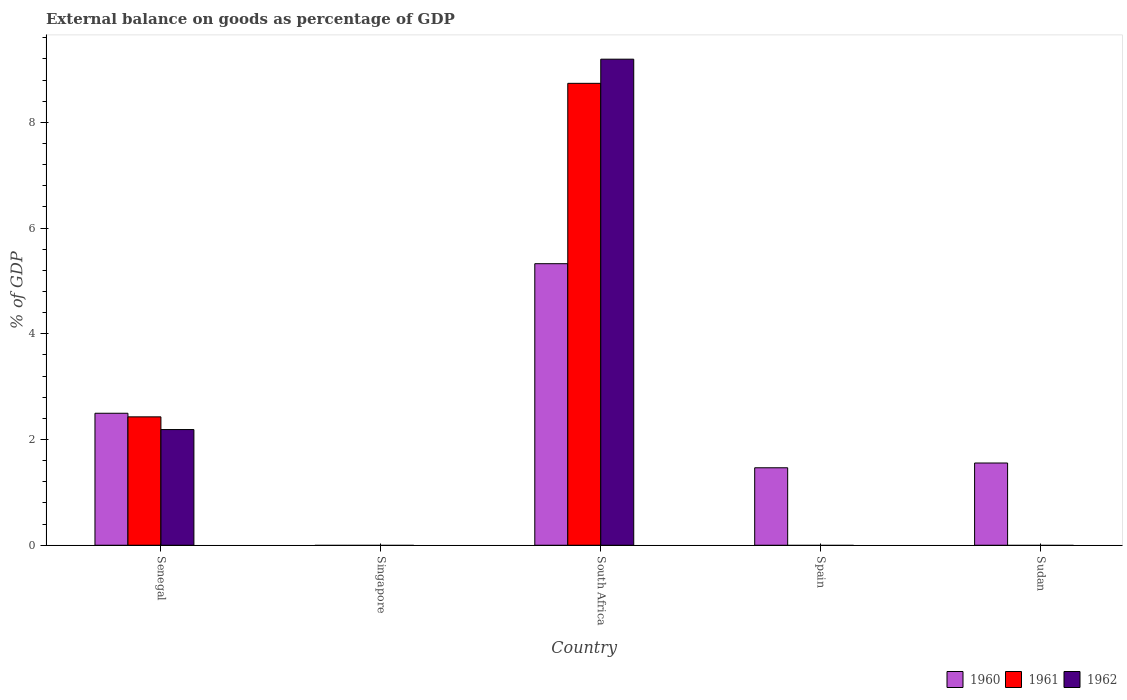Are the number of bars per tick equal to the number of legend labels?
Give a very brief answer. No. Are the number of bars on each tick of the X-axis equal?
Offer a terse response. No. How many bars are there on the 4th tick from the left?
Your response must be concise. 1. How many bars are there on the 5th tick from the right?
Make the answer very short. 3. What is the label of the 1st group of bars from the left?
Your response must be concise. Senegal. What is the external balance on goods as percentage of GDP in 1961 in Sudan?
Provide a short and direct response. 0. Across all countries, what is the maximum external balance on goods as percentage of GDP in 1962?
Give a very brief answer. 9.19. In which country was the external balance on goods as percentage of GDP in 1962 maximum?
Make the answer very short. South Africa. What is the total external balance on goods as percentage of GDP in 1962 in the graph?
Give a very brief answer. 11.38. What is the difference between the external balance on goods as percentage of GDP in 1960 in Spain and that in Sudan?
Ensure brevity in your answer.  -0.09. What is the average external balance on goods as percentage of GDP in 1961 per country?
Offer a terse response. 2.23. What is the difference between the external balance on goods as percentage of GDP of/in 1962 and external balance on goods as percentage of GDP of/in 1960 in South Africa?
Give a very brief answer. 3.87. What is the ratio of the external balance on goods as percentage of GDP in 1960 in Senegal to that in Spain?
Provide a succinct answer. 1.7. What is the difference between the highest and the second highest external balance on goods as percentage of GDP in 1960?
Provide a succinct answer. -0.94. What is the difference between the highest and the lowest external balance on goods as percentage of GDP in 1962?
Ensure brevity in your answer.  9.19. In how many countries, is the external balance on goods as percentage of GDP in 1960 greater than the average external balance on goods as percentage of GDP in 1960 taken over all countries?
Make the answer very short. 2. Is the sum of the external balance on goods as percentage of GDP in 1960 in Senegal and Sudan greater than the maximum external balance on goods as percentage of GDP in 1961 across all countries?
Provide a short and direct response. No. Are all the bars in the graph horizontal?
Offer a terse response. No. How many countries are there in the graph?
Make the answer very short. 5. How many legend labels are there?
Offer a very short reply. 3. What is the title of the graph?
Ensure brevity in your answer.  External balance on goods as percentage of GDP. Does "1978" appear as one of the legend labels in the graph?
Keep it short and to the point. No. What is the label or title of the X-axis?
Make the answer very short. Country. What is the label or title of the Y-axis?
Your answer should be compact. % of GDP. What is the % of GDP of 1960 in Senegal?
Keep it short and to the point. 2.5. What is the % of GDP of 1961 in Senegal?
Keep it short and to the point. 2.43. What is the % of GDP of 1962 in Senegal?
Keep it short and to the point. 2.19. What is the % of GDP in 1960 in Singapore?
Your answer should be very brief. 0. What is the % of GDP of 1961 in Singapore?
Provide a short and direct response. 0. What is the % of GDP of 1962 in Singapore?
Ensure brevity in your answer.  0. What is the % of GDP of 1960 in South Africa?
Offer a terse response. 5.33. What is the % of GDP of 1961 in South Africa?
Keep it short and to the point. 8.74. What is the % of GDP in 1962 in South Africa?
Your response must be concise. 9.19. What is the % of GDP in 1960 in Spain?
Ensure brevity in your answer.  1.47. What is the % of GDP in 1962 in Spain?
Your answer should be compact. 0. What is the % of GDP in 1960 in Sudan?
Keep it short and to the point. 1.56. Across all countries, what is the maximum % of GDP of 1960?
Offer a terse response. 5.33. Across all countries, what is the maximum % of GDP in 1961?
Your answer should be compact. 8.74. Across all countries, what is the maximum % of GDP of 1962?
Provide a short and direct response. 9.19. Across all countries, what is the minimum % of GDP in 1961?
Your response must be concise. 0. Across all countries, what is the minimum % of GDP of 1962?
Keep it short and to the point. 0. What is the total % of GDP in 1960 in the graph?
Ensure brevity in your answer.  10.84. What is the total % of GDP of 1961 in the graph?
Your answer should be compact. 11.17. What is the total % of GDP in 1962 in the graph?
Your answer should be compact. 11.38. What is the difference between the % of GDP in 1960 in Senegal and that in South Africa?
Provide a short and direct response. -2.83. What is the difference between the % of GDP of 1961 in Senegal and that in South Africa?
Your response must be concise. -6.31. What is the difference between the % of GDP in 1962 in Senegal and that in South Africa?
Your answer should be compact. -7.01. What is the difference between the % of GDP in 1960 in Senegal and that in Spain?
Ensure brevity in your answer.  1.03. What is the difference between the % of GDP of 1960 in Senegal and that in Sudan?
Provide a short and direct response. 0.94. What is the difference between the % of GDP in 1960 in South Africa and that in Spain?
Your answer should be compact. 3.86. What is the difference between the % of GDP of 1960 in South Africa and that in Sudan?
Offer a very short reply. 3.77. What is the difference between the % of GDP in 1960 in Spain and that in Sudan?
Offer a terse response. -0.09. What is the difference between the % of GDP in 1960 in Senegal and the % of GDP in 1961 in South Africa?
Make the answer very short. -6.24. What is the difference between the % of GDP in 1960 in Senegal and the % of GDP in 1962 in South Africa?
Give a very brief answer. -6.7. What is the difference between the % of GDP of 1961 in Senegal and the % of GDP of 1962 in South Africa?
Provide a short and direct response. -6.77. What is the average % of GDP of 1960 per country?
Offer a very short reply. 2.17. What is the average % of GDP of 1961 per country?
Offer a very short reply. 2.23. What is the average % of GDP in 1962 per country?
Offer a terse response. 2.28. What is the difference between the % of GDP of 1960 and % of GDP of 1961 in Senegal?
Your answer should be compact. 0.07. What is the difference between the % of GDP in 1960 and % of GDP in 1962 in Senegal?
Ensure brevity in your answer.  0.31. What is the difference between the % of GDP in 1961 and % of GDP in 1962 in Senegal?
Your response must be concise. 0.24. What is the difference between the % of GDP in 1960 and % of GDP in 1961 in South Africa?
Give a very brief answer. -3.41. What is the difference between the % of GDP in 1960 and % of GDP in 1962 in South Africa?
Your answer should be very brief. -3.87. What is the difference between the % of GDP of 1961 and % of GDP of 1962 in South Africa?
Your response must be concise. -0.46. What is the ratio of the % of GDP of 1960 in Senegal to that in South Africa?
Offer a very short reply. 0.47. What is the ratio of the % of GDP in 1961 in Senegal to that in South Africa?
Give a very brief answer. 0.28. What is the ratio of the % of GDP in 1962 in Senegal to that in South Africa?
Ensure brevity in your answer.  0.24. What is the ratio of the % of GDP in 1960 in Senegal to that in Spain?
Give a very brief answer. 1.7. What is the ratio of the % of GDP of 1960 in Senegal to that in Sudan?
Your answer should be compact. 1.61. What is the ratio of the % of GDP of 1960 in South Africa to that in Spain?
Give a very brief answer. 3.63. What is the ratio of the % of GDP of 1960 in South Africa to that in Sudan?
Offer a terse response. 3.42. What is the ratio of the % of GDP of 1960 in Spain to that in Sudan?
Offer a very short reply. 0.94. What is the difference between the highest and the second highest % of GDP of 1960?
Your response must be concise. 2.83. What is the difference between the highest and the lowest % of GDP in 1960?
Provide a succinct answer. 5.33. What is the difference between the highest and the lowest % of GDP of 1961?
Provide a short and direct response. 8.74. What is the difference between the highest and the lowest % of GDP of 1962?
Give a very brief answer. 9.19. 